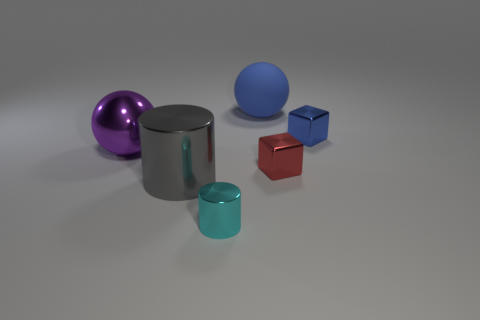Add 2 big purple cylinders. How many objects exist? 8 Subtract all cyan cylinders. How many cylinders are left? 1 Subtract all spheres. How many objects are left? 4 Subtract all purple cylinders. Subtract all red cubes. How many cylinders are left? 2 Subtract all brown cylinders. How many green spheres are left? 0 Subtract all green cubes. Subtract all cubes. How many objects are left? 4 Add 2 purple shiny things. How many purple shiny things are left? 3 Add 1 big red things. How many big red things exist? 1 Subtract 1 blue spheres. How many objects are left? 5 Subtract 2 cubes. How many cubes are left? 0 